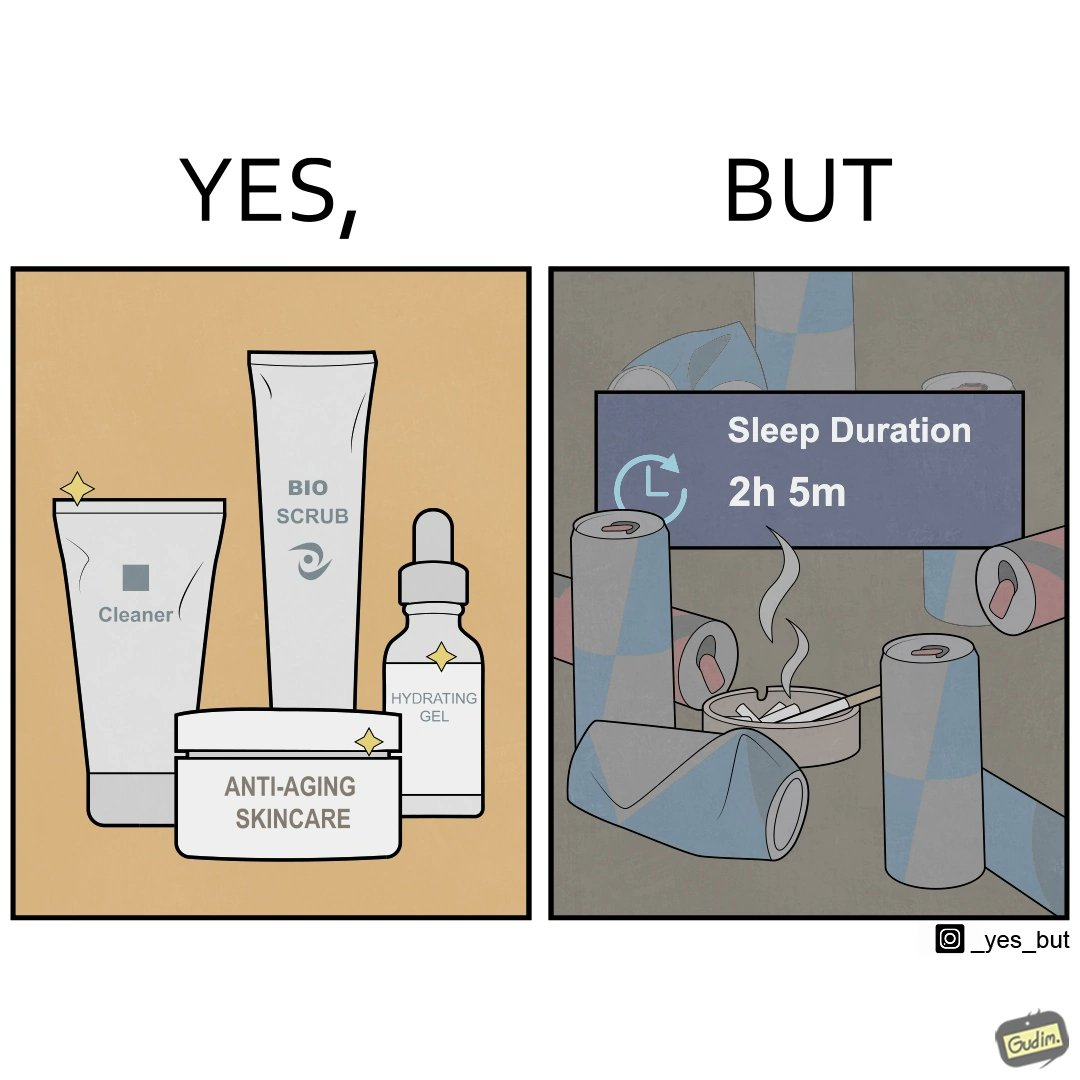Would you classify this image as satirical? Yes, this image is satirical. 